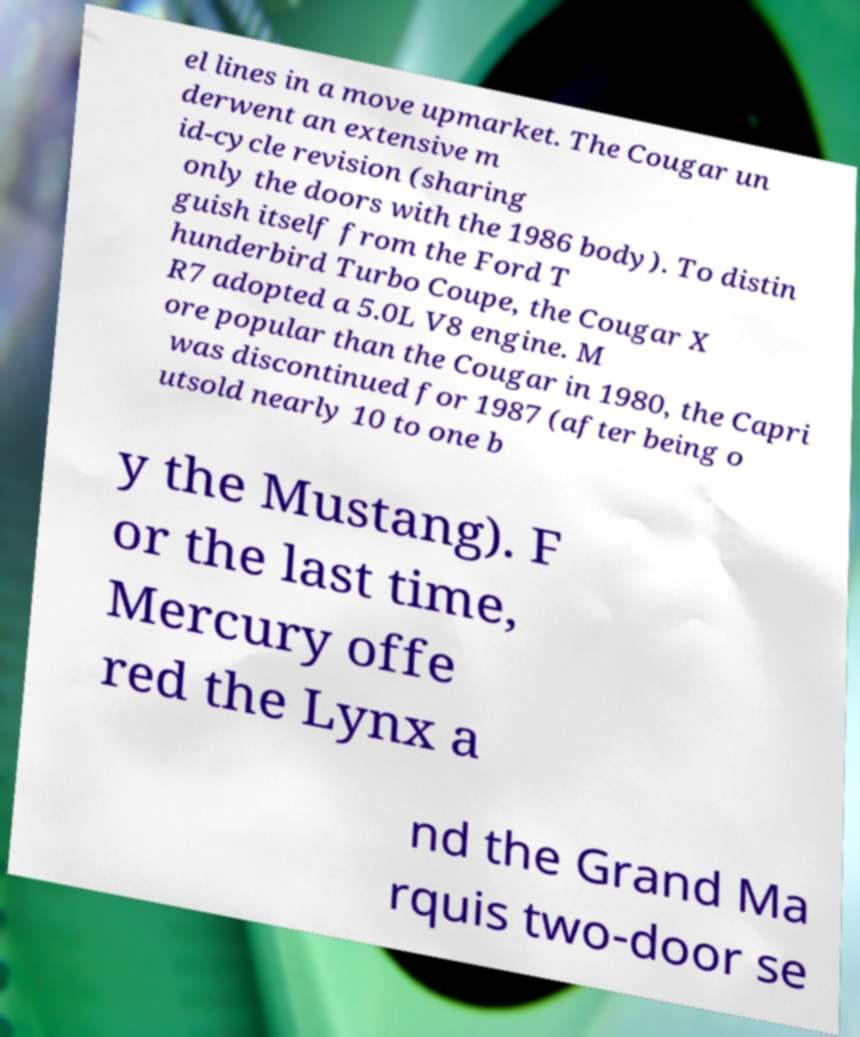Can you accurately transcribe the text from the provided image for me? el lines in a move upmarket. The Cougar un derwent an extensive m id-cycle revision (sharing only the doors with the 1986 body). To distin guish itself from the Ford T hunderbird Turbo Coupe, the Cougar X R7 adopted a 5.0L V8 engine. M ore popular than the Cougar in 1980, the Capri was discontinued for 1987 (after being o utsold nearly 10 to one b y the Mustang). F or the last time, Mercury offe red the Lynx a nd the Grand Ma rquis two-door se 